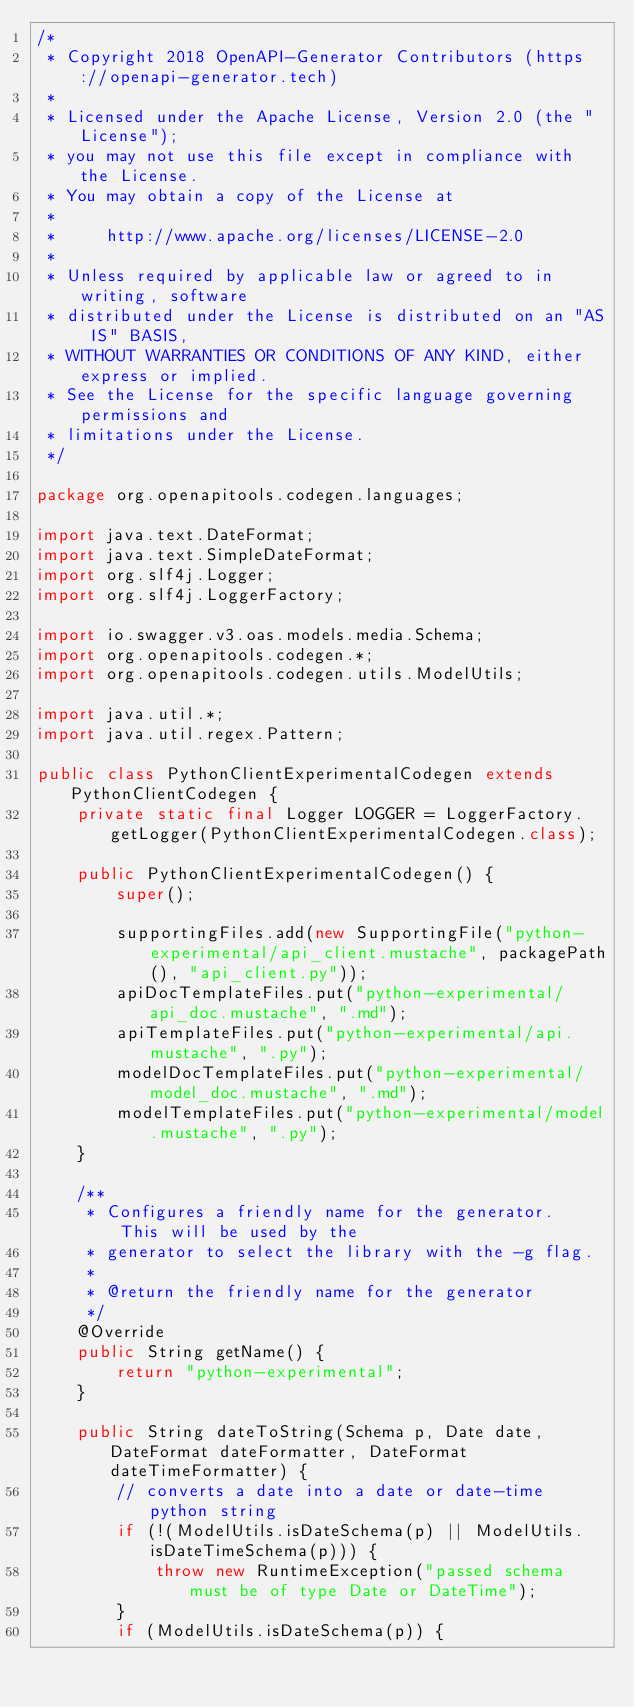<code> <loc_0><loc_0><loc_500><loc_500><_Java_>/*
 * Copyright 2018 OpenAPI-Generator Contributors (https://openapi-generator.tech)
 *
 * Licensed under the Apache License, Version 2.0 (the "License");
 * you may not use this file except in compliance with the License.
 * You may obtain a copy of the License at
 *
 *     http://www.apache.org/licenses/LICENSE-2.0
 *
 * Unless required by applicable law or agreed to in writing, software
 * distributed under the License is distributed on an "AS IS" BASIS,
 * WITHOUT WARRANTIES OR CONDITIONS OF ANY KIND, either express or implied.
 * See the License for the specific language governing permissions and
 * limitations under the License.
 */

package org.openapitools.codegen.languages;

import java.text.DateFormat;
import java.text.SimpleDateFormat;
import org.slf4j.Logger;
import org.slf4j.LoggerFactory;

import io.swagger.v3.oas.models.media.Schema;
import org.openapitools.codegen.*;
import org.openapitools.codegen.utils.ModelUtils;

import java.util.*;
import java.util.regex.Pattern;

public class PythonClientExperimentalCodegen extends PythonClientCodegen {
    private static final Logger LOGGER = LoggerFactory.getLogger(PythonClientExperimentalCodegen.class);

    public PythonClientExperimentalCodegen() {
        super();

        supportingFiles.add(new SupportingFile("python-experimental/api_client.mustache", packagePath(), "api_client.py"));
        apiDocTemplateFiles.put("python-experimental/api_doc.mustache", ".md");
        apiTemplateFiles.put("python-experimental/api.mustache", ".py");
        modelDocTemplateFiles.put("python-experimental/model_doc.mustache", ".md");
        modelTemplateFiles.put("python-experimental/model.mustache", ".py");
    }

    /**
     * Configures a friendly name for the generator.  This will be used by the
     * generator to select the library with the -g flag.
     *
     * @return the friendly name for the generator
     */
    @Override
    public String getName() {
        return "python-experimental";
    }

    public String dateToString(Schema p, Date date, DateFormat dateFormatter, DateFormat dateTimeFormatter) {
        // converts a date into a date or date-time python string
        if (!(ModelUtils.isDateSchema(p) || ModelUtils.isDateTimeSchema(p))) {
            throw new RuntimeException("passed schema must be of type Date or DateTime");
        }
        if (ModelUtils.isDateSchema(p)) {</code> 